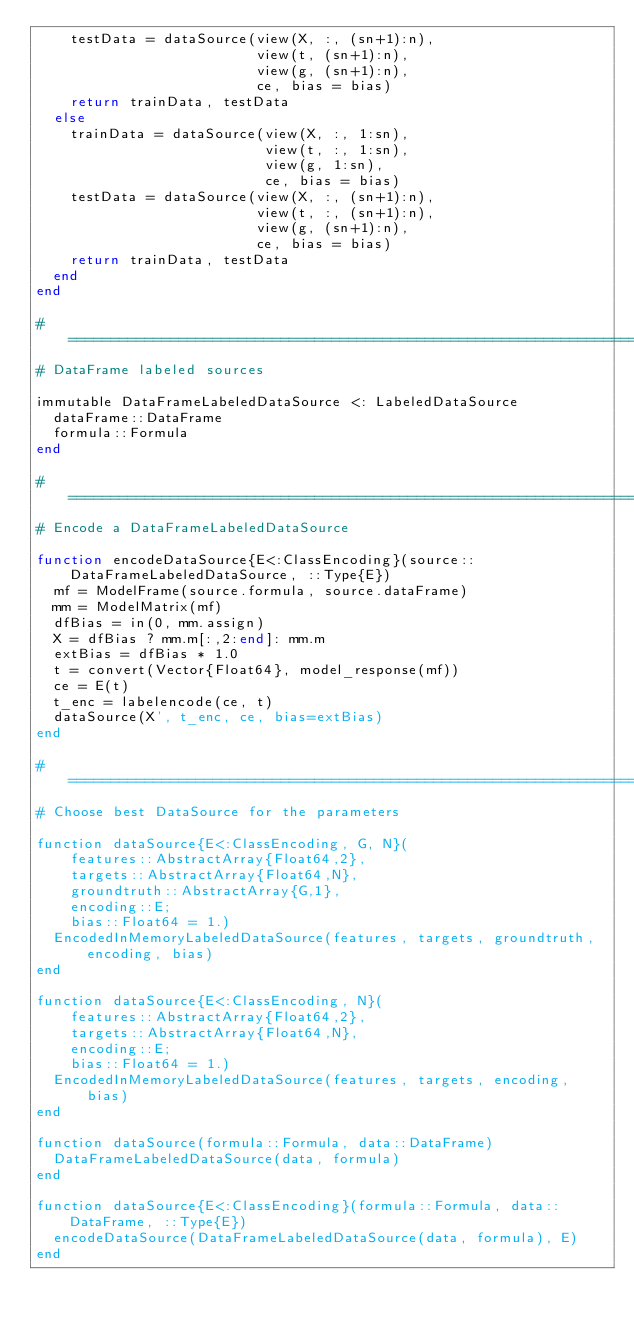Convert code to text. <code><loc_0><loc_0><loc_500><loc_500><_Julia_>    testData = dataSource(view(X, :, (sn+1):n),
                          view(t, (sn+1):n),
                          view(g, (sn+1):n),
                          ce, bias = bias)
    return trainData, testData
  else
    trainData = dataSource(view(X, :, 1:sn),
                           view(t, :, 1:sn),
                           view(g, 1:sn),
                           ce, bias = bias)
    testData = dataSource(view(X, :, (sn+1):n),
                          view(t, :, (sn+1):n),
                          view(g, (sn+1):n),
                          ce, bias = bias)
    return trainData, testData
  end
end

# ==========================================================================
# DataFrame labeled sources

immutable DataFrameLabeledDataSource <: LabeledDataSource
  dataFrame::DataFrame
  formula::Formula
end

# ==========================================================================
# Encode a DataFrameLabeledDataSource

function encodeDataSource{E<:ClassEncoding}(source::DataFrameLabeledDataSource, ::Type{E})
  mf = ModelFrame(source.formula, source.dataFrame)
  mm = ModelMatrix(mf)
  dfBias = in(0, mm.assign)
  X = dfBias ? mm.m[:,2:end]: mm.m
  extBias = dfBias * 1.0
  t = convert(Vector{Float64}, model_response(mf))
  ce = E(t)
  t_enc = labelencode(ce, t)
  dataSource(X', t_enc, ce, bias=extBias)
end

# ==========================================================================
# Choose best DataSource for the parameters

function dataSource{E<:ClassEncoding, G, N}(
    features::AbstractArray{Float64,2},
    targets::AbstractArray{Float64,N},
    groundtruth::AbstractArray{G,1},
    encoding::E;
    bias::Float64 = 1.)
  EncodedInMemoryLabeledDataSource(features, targets, groundtruth, encoding, bias)
end

function dataSource{E<:ClassEncoding, N}(
    features::AbstractArray{Float64,2},
    targets::AbstractArray{Float64,N},
    encoding::E;
    bias::Float64 = 1.)
  EncodedInMemoryLabeledDataSource(features, targets, encoding, bias)
end

function dataSource(formula::Formula, data::DataFrame)
  DataFrameLabeledDataSource(data, formula)
end

function dataSource{E<:ClassEncoding}(formula::Formula, data::DataFrame, ::Type{E})
  encodeDataSource(DataFrameLabeledDataSource(data, formula), E)
end
</code> 